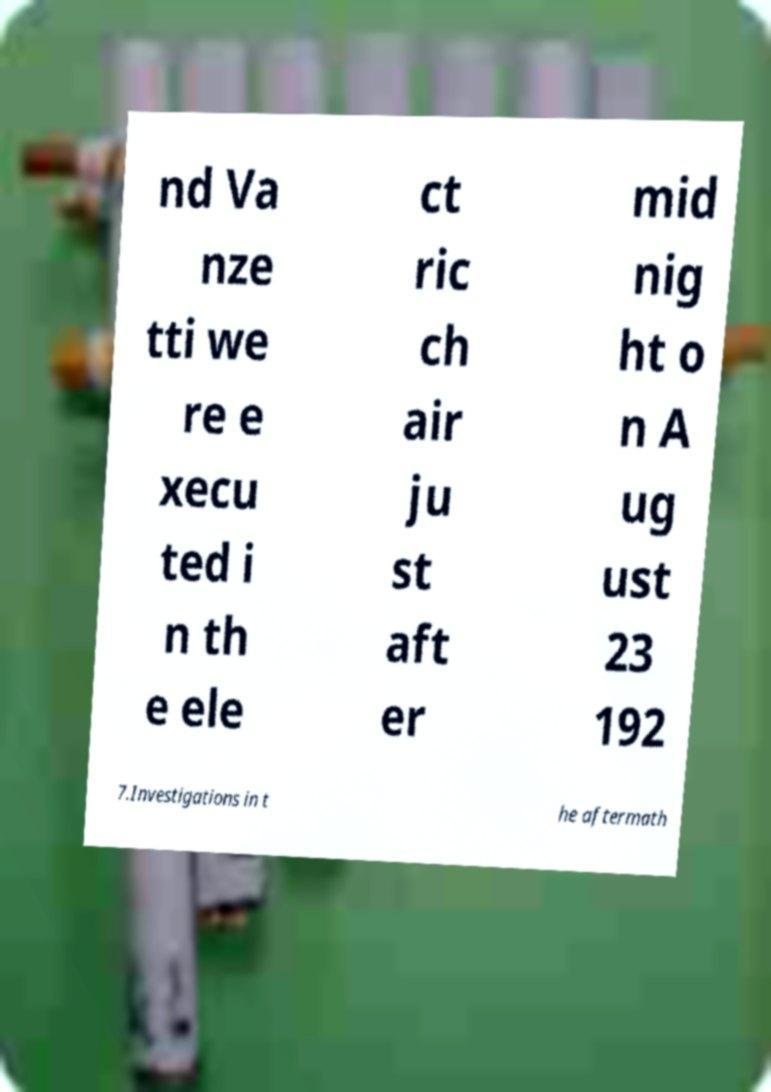Please identify and transcribe the text found in this image. nd Va nze tti we re e xecu ted i n th e ele ct ric ch air ju st aft er mid nig ht o n A ug ust 23 192 7.Investigations in t he aftermath 